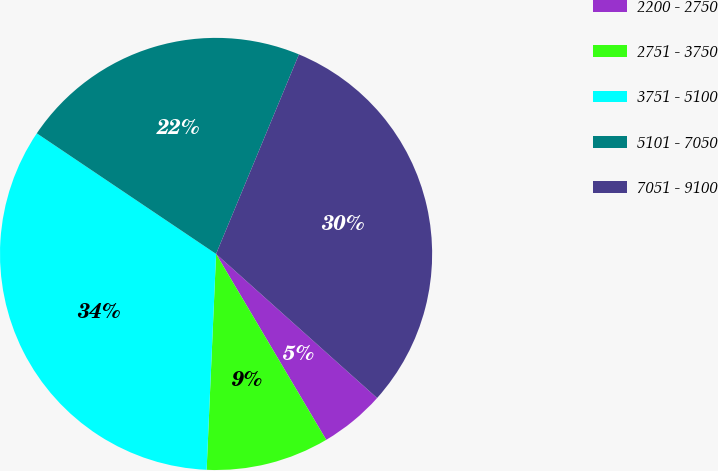Convert chart. <chart><loc_0><loc_0><loc_500><loc_500><pie_chart><fcel>2200 - 2750<fcel>2751 - 3750<fcel>3751 - 5100<fcel>5101 - 7050<fcel>7051 - 9100<nl><fcel>4.87%<fcel>9.21%<fcel>33.73%<fcel>21.84%<fcel>30.35%<nl></chart> 